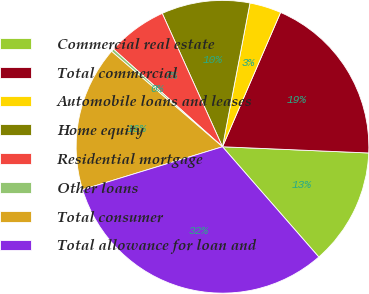Convert chart. <chart><loc_0><loc_0><loc_500><loc_500><pie_chart><fcel>Commercial real estate<fcel>Total commercial<fcel>Automobile loans and leases<fcel>Home equity<fcel>Residential mortgage<fcel>Other loans<fcel>Total consumer<fcel>Total allowance for loan and<nl><fcel>12.9%<fcel>19.18%<fcel>3.49%<fcel>9.76%<fcel>6.62%<fcel>0.32%<fcel>16.04%<fcel>31.7%<nl></chart> 